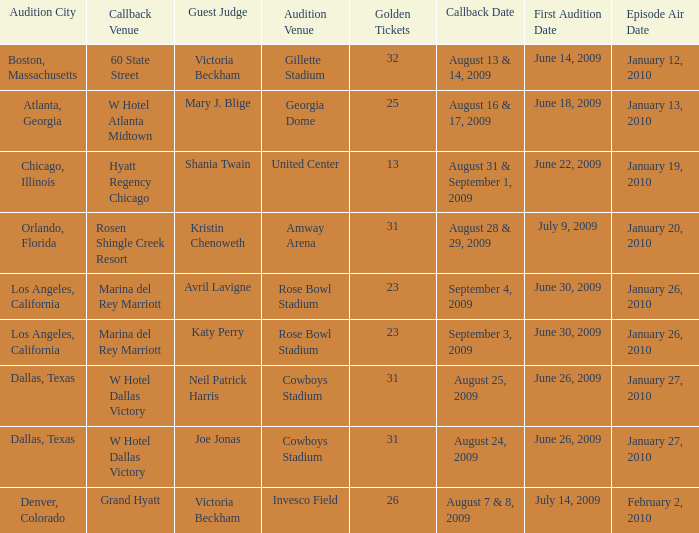Name the guest judge for first audition date being july 9, 2009 1.0. 